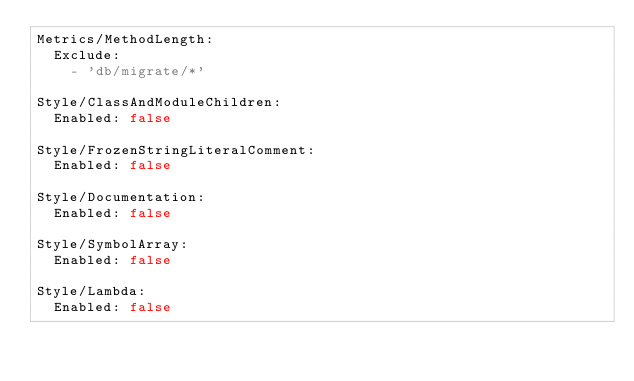Convert code to text. <code><loc_0><loc_0><loc_500><loc_500><_YAML_>Metrics/MethodLength:
  Exclude:
    - 'db/migrate/*'

Style/ClassAndModuleChildren:
  Enabled: false

Style/FrozenStringLiteralComment:
  Enabled: false

Style/Documentation:
  Enabled: false

Style/SymbolArray:
  Enabled: false

Style/Lambda:
  Enabled: false
</code> 